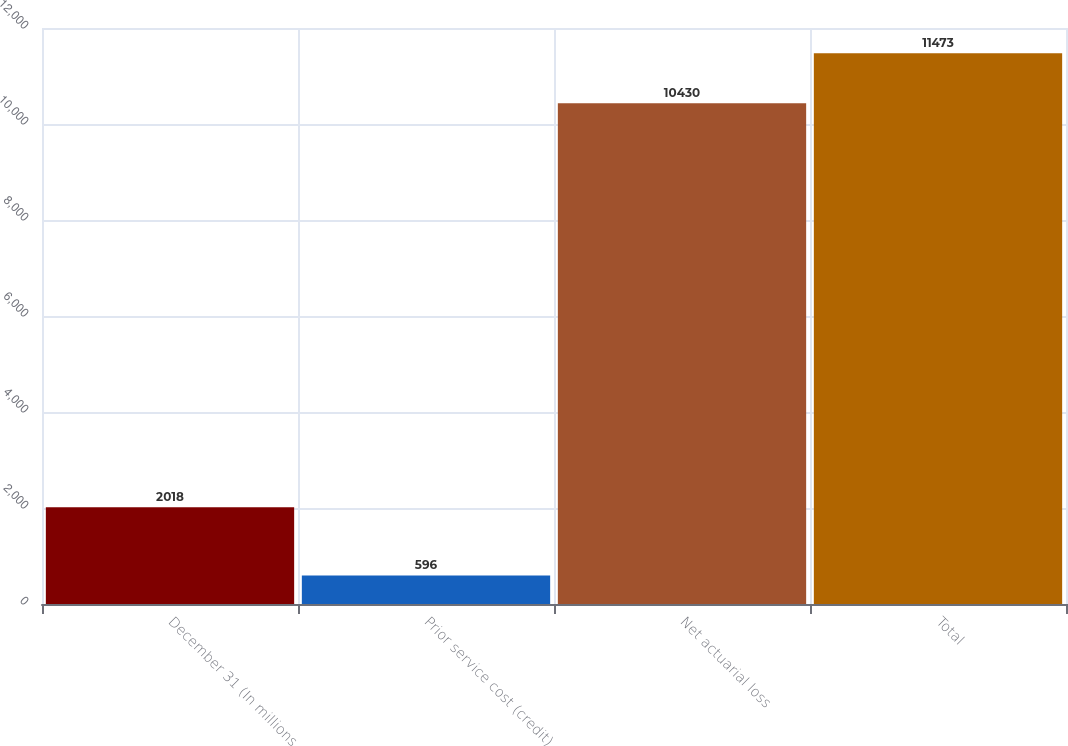Convert chart to OTSL. <chart><loc_0><loc_0><loc_500><loc_500><bar_chart><fcel>December 31 (In millions<fcel>Prior service cost (credit)<fcel>Net actuarial loss<fcel>Total<nl><fcel>2018<fcel>596<fcel>10430<fcel>11473<nl></chart> 